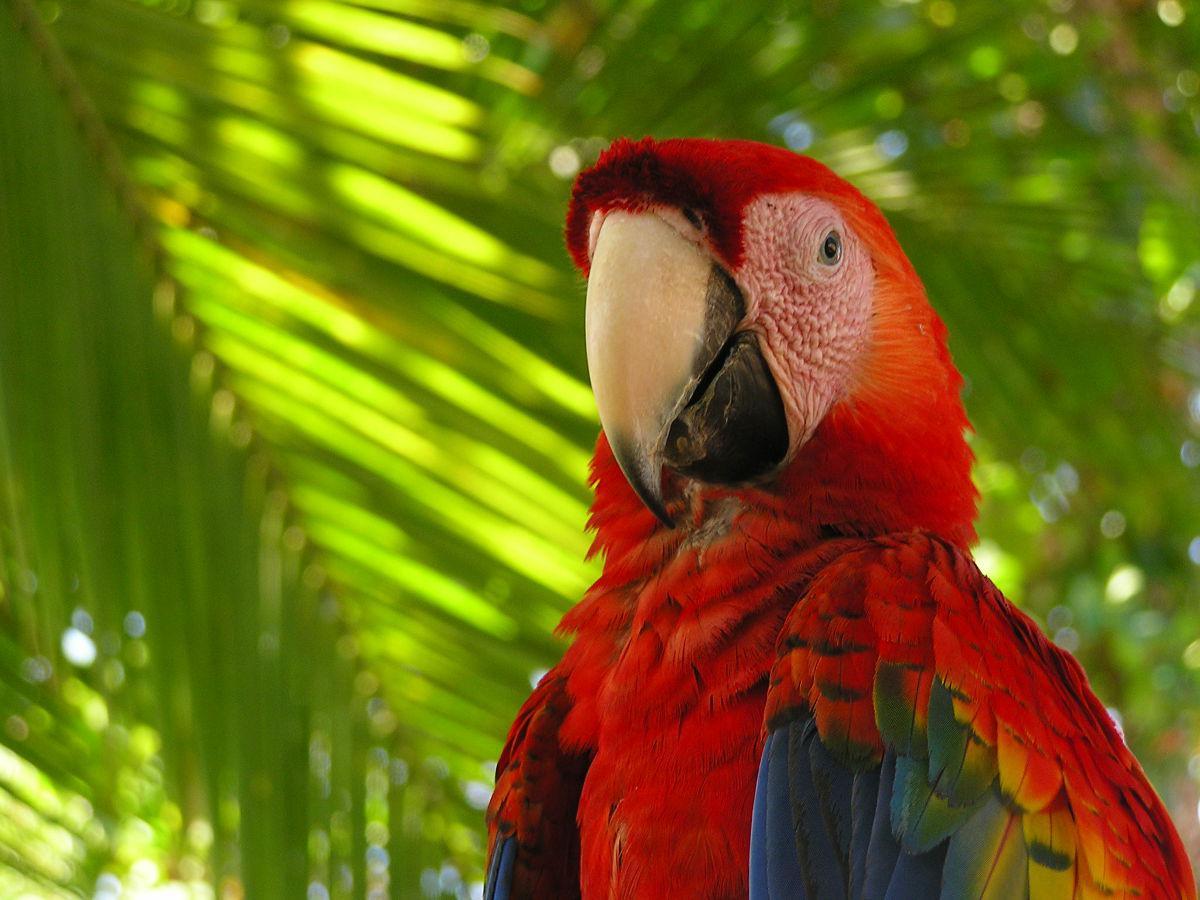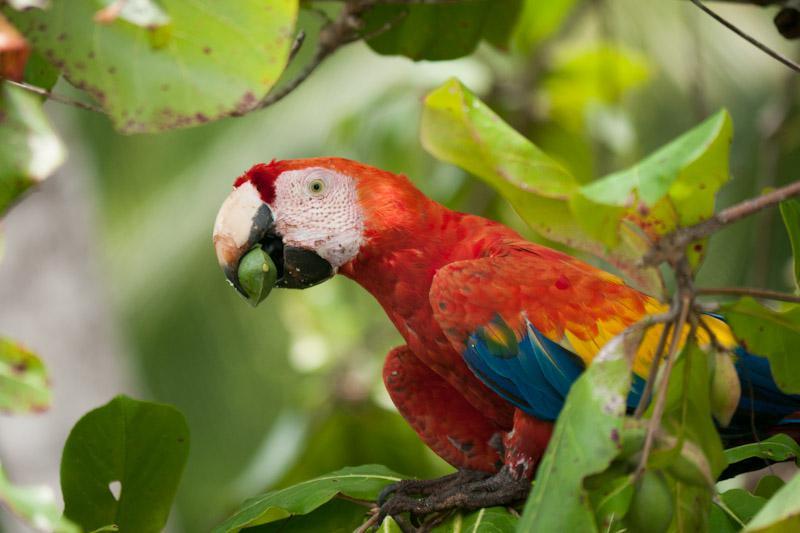The first image is the image on the left, the second image is the image on the right. For the images displayed, is the sentence "A bird looking to the left has something green in its mouth." factually correct? Answer yes or no. Yes. 